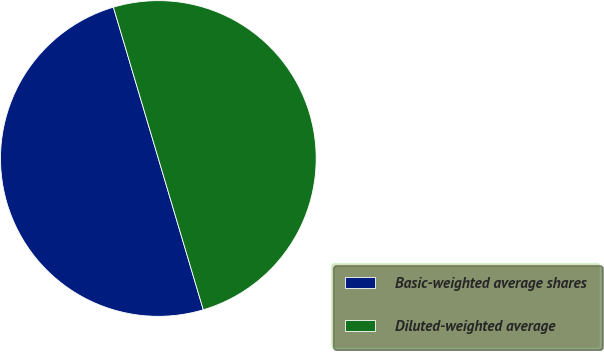Convert chart to OTSL. <chart><loc_0><loc_0><loc_500><loc_500><pie_chart><fcel>Basic-weighted average shares<fcel>Diluted-weighted average<nl><fcel>50.0%<fcel>50.0%<nl></chart> 